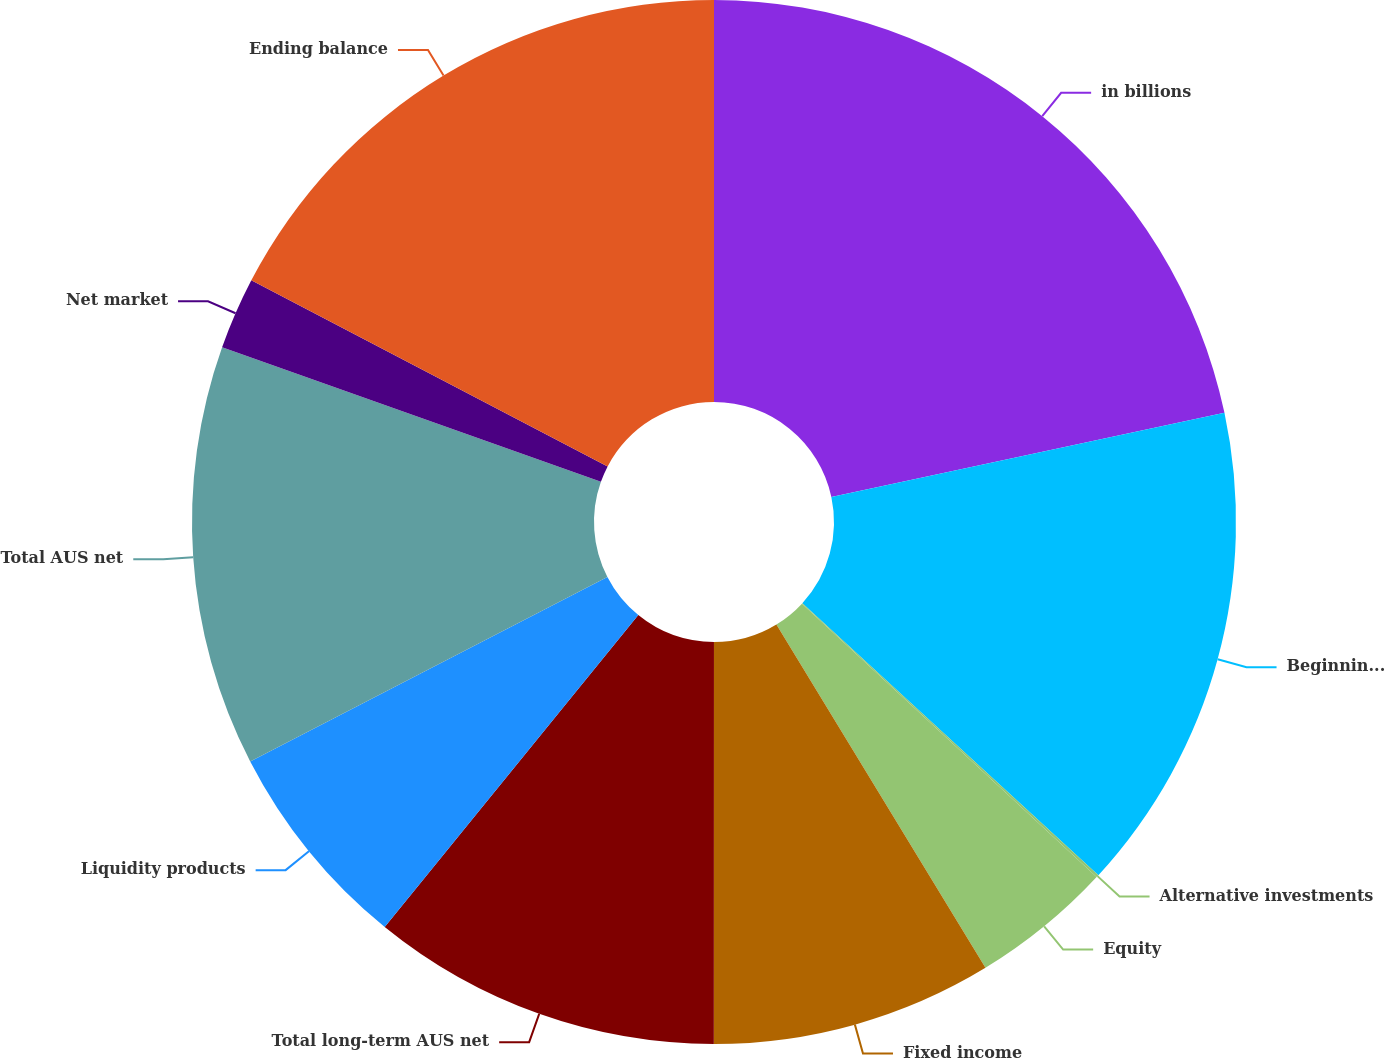Convert chart. <chart><loc_0><loc_0><loc_500><loc_500><pie_chart><fcel>in billions<fcel>Beginning balance<fcel>Alternative investments<fcel>Equity<fcel>Fixed income<fcel>Total long-term AUS net<fcel>Liquidity products<fcel>Total AUS net<fcel>Net market<fcel>Ending balance<nl><fcel>21.65%<fcel>15.18%<fcel>0.08%<fcel>4.39%<fcel>8.71%<fcel>10.86%<fcel>6.55%<fcel>13.02%<fcel>2.23%<fcel>17.34%<nl></chart> 